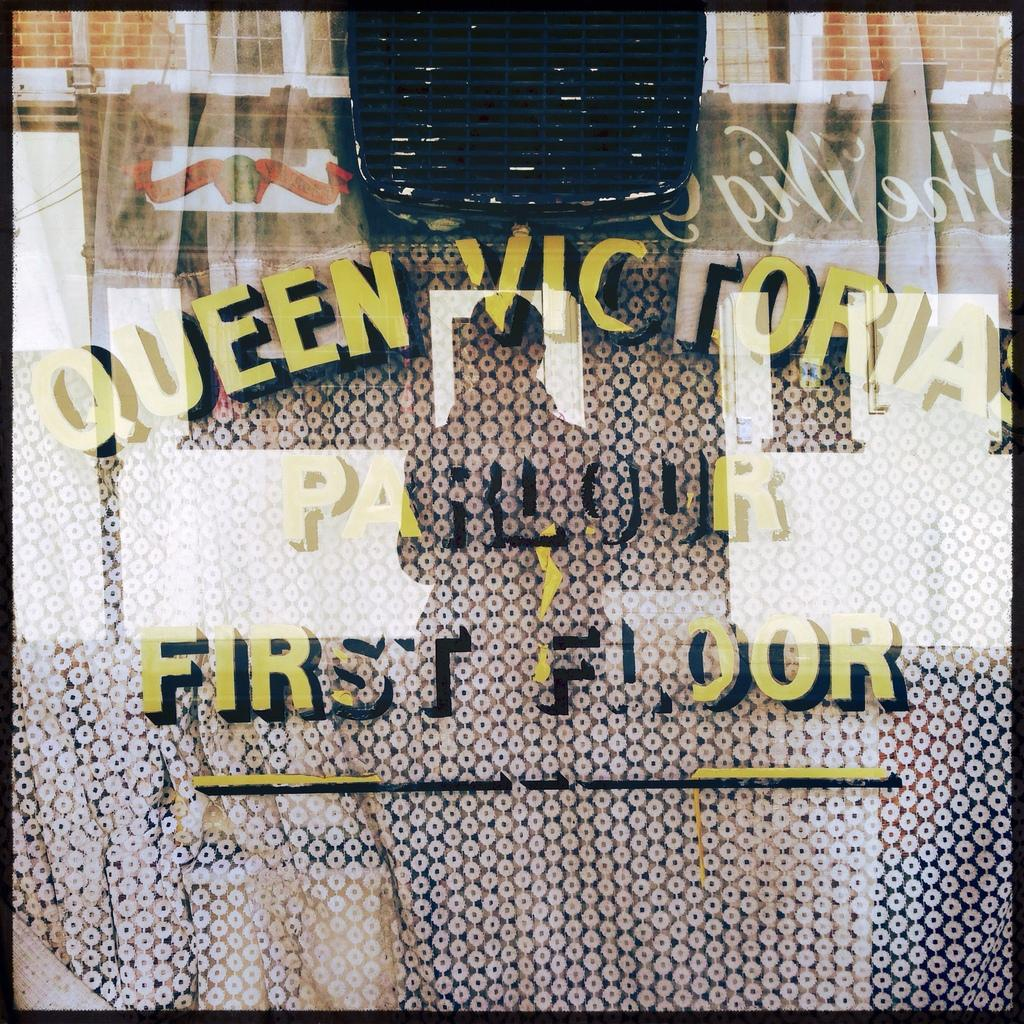Provide a one-sentence caption for the provided image. The name of the Queen Victoria parlour is etched in painting black and yellow paint on a window. 